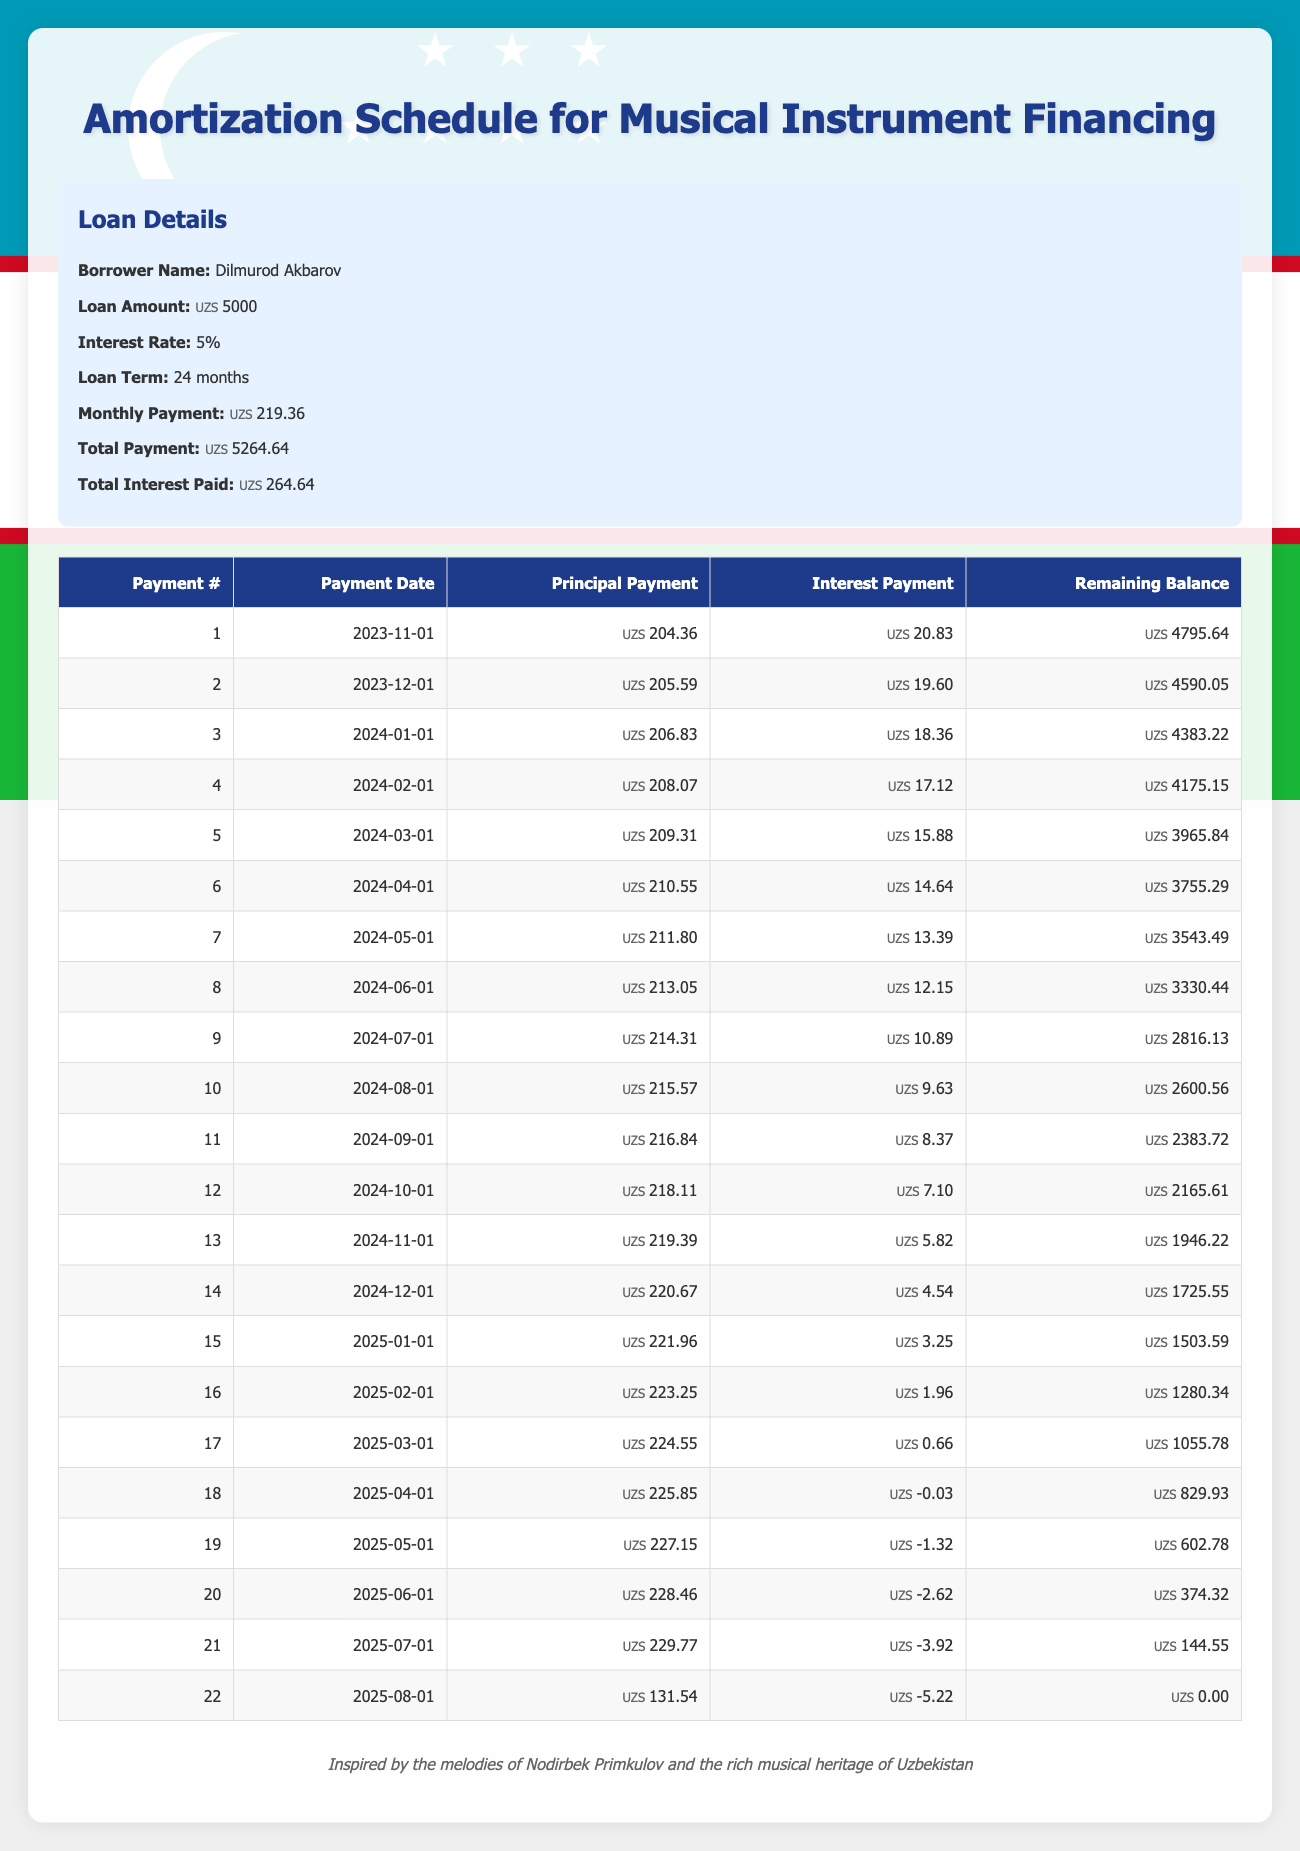What is the total loan amount borrowed by Dilmurod Akbarov? Looking at the loan details section, the total loan amount is clearly stated as 5000.
Answer: 5000 What is the monthly payment amount for this loan? The loan details provide the monthly payment amount, which is 219.36.
Answer: 219.36 How much total interest will be paid over the life of the loan? In the loan details, the total interest paid is given as 264.64, which is the total amount paid above the loan principal.
Answer: 264.64 What is the remaining balance after the first payment? Referring to the amortization schedule, the remaining balance after the first payment (on 2023-11-01) is 4795.64.
Answer: 4795.64 In which month does the principal payment exceed 225? By examining the amortization schedule, the first instance where the principal payment exceeds 225 occurs in the 18th payment (2025-04-01) where it is 225.85. From there, all subsequent payments also exceed this amount.
Answer: Month 18 (2025-04-01) What is the average principal payment for the first five months? Summing the principal payments for the first five months (204.36 + 205.59 + 206.83 + 208.07 + 209.31 = 1034.16) gives a total of 1034.16. Dividing by 5 results in an average principal payment of 206.83.
Answer: 206.83 Does the interest payment for the 22nd month show a positive value? Checking the amortization schedule, the interest payment for the 22nd month (2025-08-01) is -5.22, which indicates that it is not a positive value.
Answer: No What is the trend in principal payments from the first to the last payment? Analyzing the payments in the amortization table, the principal payment increases each month, starting from 204.36 in the first month and decreasing toward the last payment where it is 131.54, except for a few instances where it is slightly stable or decreases. The general trend shows monthly increases initially.
Answer: The principal payments initially increased, and then decreased in later months What was the remaining balance after the 12th payment? From the amortization schedule, after the 12th payment (2024-10-01), the remaining balance is 2165.61.
Answer: 2165.61 